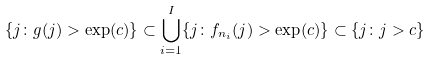Convert formula to latex. <formula><loc_0><loc_0><loc_500><loc_500>\{ j \colon g ( j ) > \exp ( c ) \} \subset \bigcup _ { i = 1 } ^ { I } \{ j \colon f _ { n _ { i } } ( j ) > \exp ( c ) \} \subset \{ j \colon j > c \}</formula> 